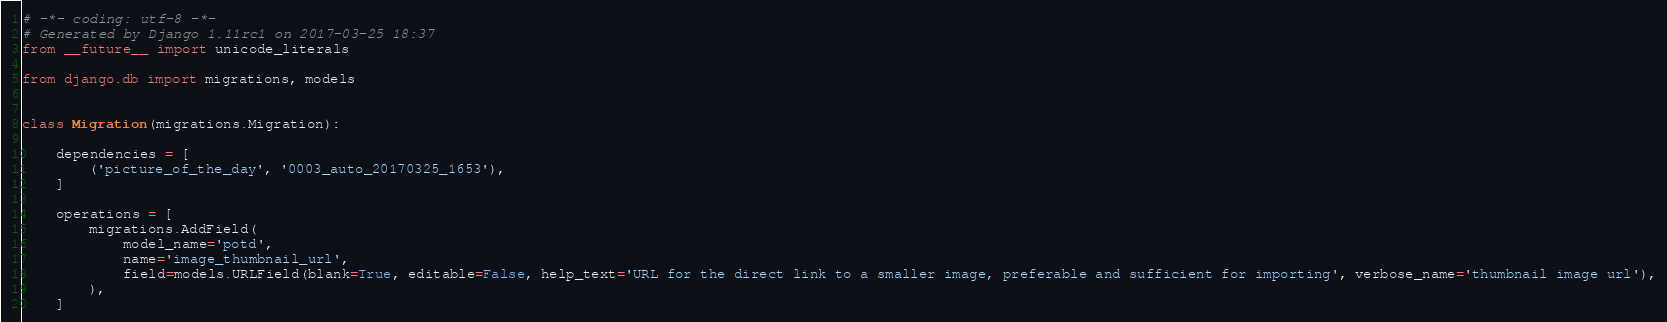Convert code to text. <code><loc_0><loc_0><loc_500><loc_500><_Python_># -*- coding: utf-8 -*-
# Generated by Django 1.11rc1 on 2017-03-25 18:37
from __future__ import unicode_literals

from django.db import migrations, models


class Migration(migrations.Migration):

    dependencies = [
        ('picture_of_the_day', '0003_auto_20170325_1653'),
    ]

    operations = [
        migrations.AddField(
            model_name='potd',
            name='image_thumbnail_url',
            field=models.URLField(blank=True, editable=False, help_text='URL for the direct link to a smaller image, preferable and sufficient for importing', verbose_name='thumbnail image url'),
        ),
    ]
</code> 